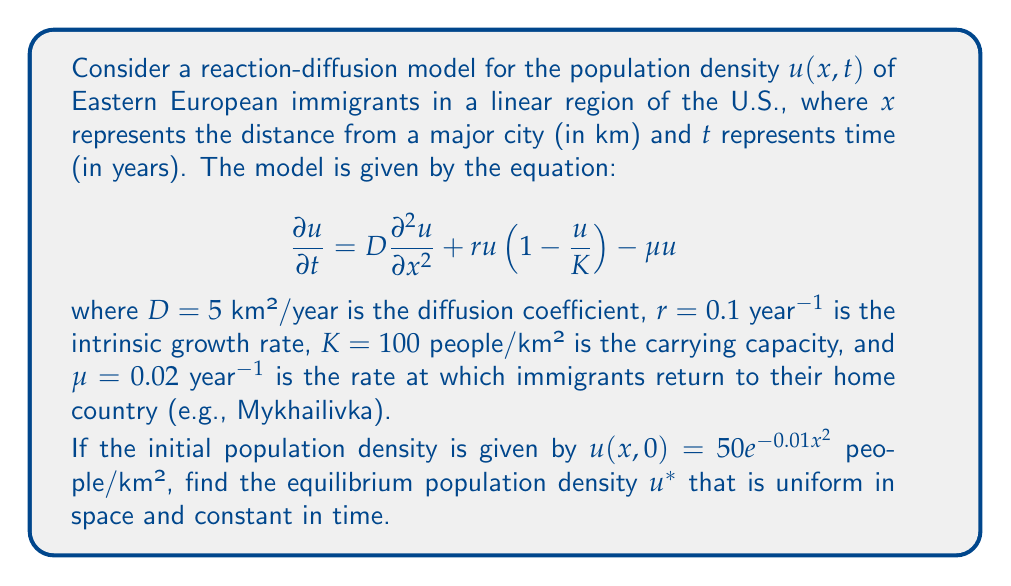Show me your answer to this math problem. To find the equilibrium population density $u^*$, we need to solve the equation when the time derivative and spatial derivatives are zero:

1) At equilibrium, $\frac{\partial u}{\partial t} = 0$ and $\frac{\partial^2 u}{\partial x^2} = 0$

2) Substituting these into the original equation:

   $$0 = 0 + ru^*(1-\frac{u^*}{K}) - \mu u^*$$

3) Factoring out $u^*$:

   $$u^*(r(1-\frac{u^*}{K}) - \mu) = 0$$

4) This equation has two solutions: $u^* = 0$ or $r(1-\frac{u^*}{K}) - \mu = 0$

5) The non-zero solution is more interesting, so let's solve:

   $$r(1-\frac{u^*}{K}) - \mu = 0$$
   $$r - \frac{ru^*}{K} - \mu = 0$$
   $$r - \mu = \frac{ru^*}{K}$$
   $$K(r - \mu) = ru^*$$
   $$u^* = K(1 - \frac{\mu}{r})$$

6) Substituting the given values:

   $$u^* = 100(1 - \frac{0.02}{0.1}) = 100(1 - 0.2) = 80$$

Therefore, the equilibrium population density is 80 people/km².
Answer: $u^* = 80$ people/km² 